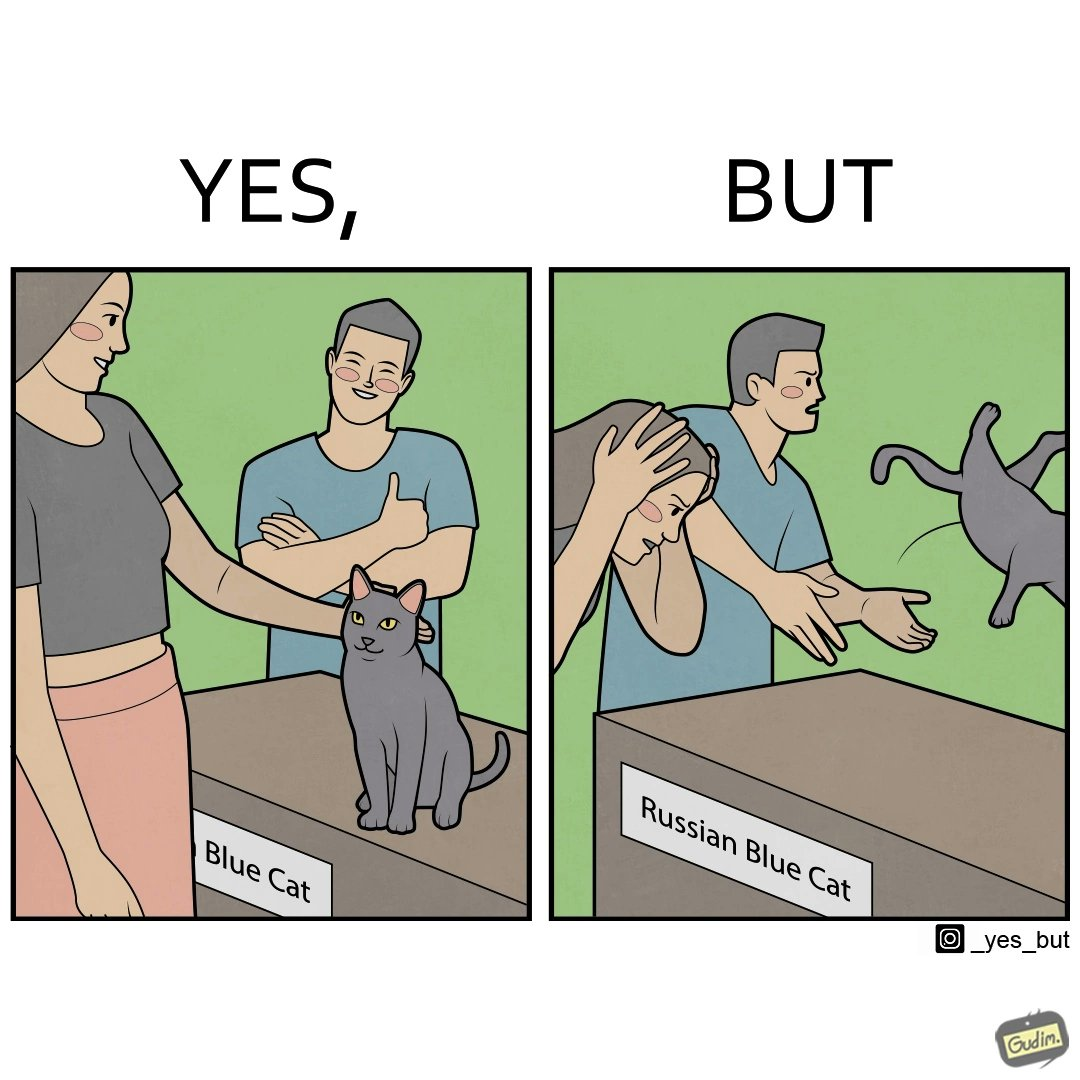Is this image satirical or non-satirical? Yes, this image is satirical. 